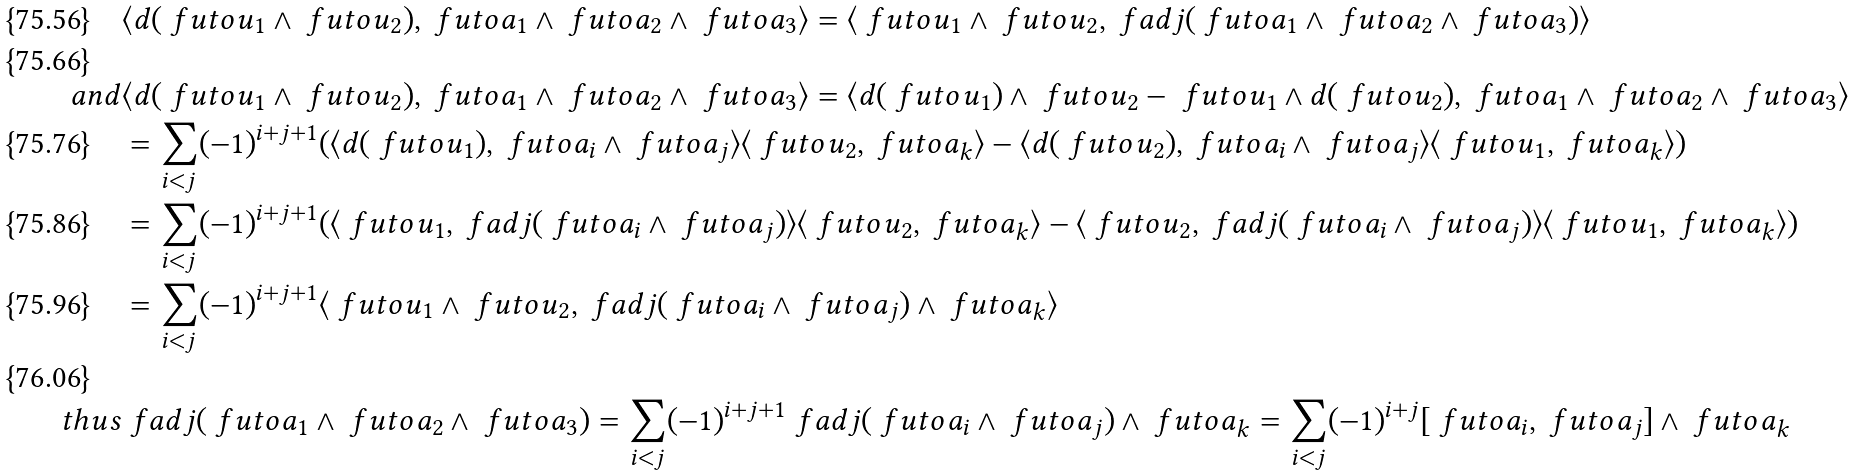<formula> <loc_0><loc_0><loc_500><loc_500>& \langle d ( \ f u t o { u } _ { 1 } \wedge \ f u t o { u } _ { 2 } ) , \ f u t o { a } _ { 1 } \wedge \ f u t o { a } _ { 2 } \wedge \ f u t o { a } _ { 3 } \rangle = \langle \ f u t o { u } _ { 1 } \wedge \ f u t o { u } _ { 2 } , \ f a d j ( \ f u t o { a } _ { 1 } \wedge \ f u t o { a } _ { 2 } \wedge \ f u t o { a } _ { 3 } ) \rangle \\ { a n d } & \langle d ( \ f u t o { u } _ { 1 } \wedge \ f u t o { u } _ { 2 } ) , \ f u t o { a } _ { 1 } \wedge \ f u t o { a } _ { 2 } \wedge \ f u t o { a } _ { 3 } \rangle = \langle d ( \ f u t o { u } _ { 1 } ) \wedge \ f u t o { u } _ { 2 } - \ f u t o { u } _ { 1 } \wedge d ( \ f u t o { u } _ { 2 } ) , \ f u t o { a } _ { 1 } \wedge \ f u t o { a } _ { 2 } \wedge \ f u t o { a } _ { 3 } \rangle \\ & = \sum _ { i < j } ( - 1 ) ^ { i + j + 1 } ( \langle d ( \ f u t o { u } _ { 1 } ) , \ f u t o { a } _ { i } \wedge \ f u t o { a } _ { j } \rangle \langle \ f u t o { u } _ { 2 } , \ f u t o { a } _ { k } \rangle - \langle d ( \ f u t o { u } _ { 2 } ) , \ f u t o { a } _ { i } \wedge \ f u t o { a } _ { j } \rangle \langle \ f u t o { u } _ { 1 } , \ f u t o { a } _ { k } \rangle ) \\ & = \sum _ { i < j } ( - 1 ) ^ { i + j + 1 } ( \langle \ f u t o { u } _ { 1 } , \ f a d j ( \ f u t o { a } _ { i } \wedge \ f u t o { a } _ { j } ) \rangle \langle \ f u t o { u } _ { 2 } , \ f u t o { a } _ { k } \rangle - \langle \ f u t o { u } _ { 2 } , \ f a d j ( \ f u t o { a } _ { i } \wedge \ f u t o { a } _ { j } ) \rangle \langle \ f u t o { u } _ { 1 } , \ f u t o { a } _ { k } \rangle ) \\ & = \sum _ { i < j } ( - 1 ) ^ { i + j + 1 } \langle \ f u t o { u } _ { 1 } \wedge \ f u t o { u } _ { 2 } , \ f a d j ( \ f u t o { a } _ { i } \wedge \ f u t o { a } _ { j } ) \wedge \ f u t o { a } _ { k } \rangle \\ { t h u s } & \ f a d j ( \ f u t o { a } _ { 1 } \wedge \ f u t o { a } _ { 2 } \wedge \ f u t o { a } _ { 3 } ) = \sum _ { i < j } ( - 1 ) ^ { i + j + 1 } \ f a d j ( \ f u t o { a } _ { i } \wedge \ f u t o { a } _ { j } ) \wedge \ f u t o { a } _ { k } = \sum _ { i < j } ( - 1 ) ^ { i + j } [ \ f u t o { a } _ { i } , \ f u t o { a } _ { j } ] \wedge \ f u t o { a } _ { k }</formula> 